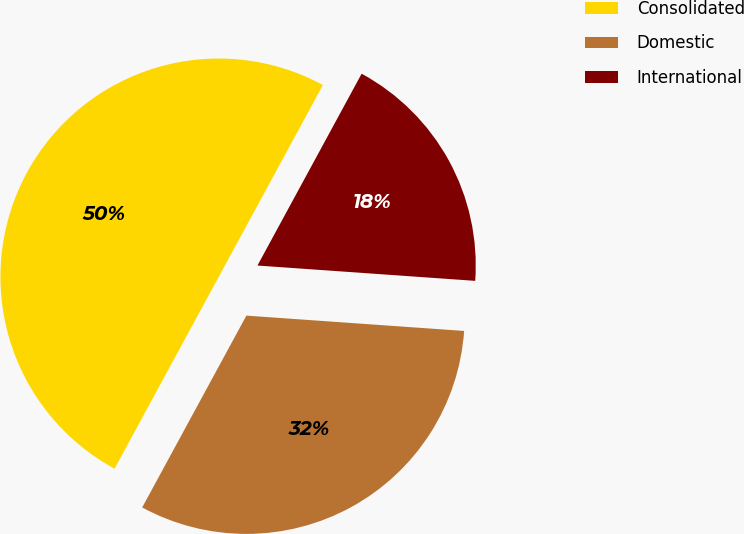<chart> <loc_0><loc_0><loc_500><loc_500><pie_chart><fcel>Consolidated<fcel>Domestic<fcel>International<nl><fcel>50.0%<fcel>31.8%<fcel>18.2%<nl></chart> 